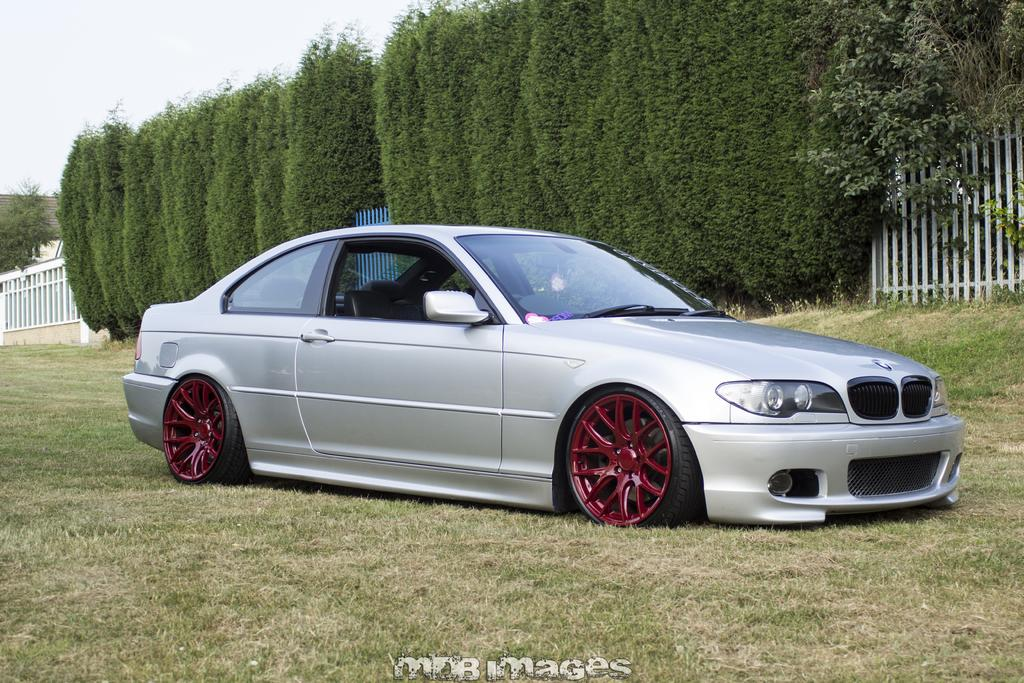What color is the car in the image? The car in the image is silver. Where is the car located in the image? The car is parked on the grass. What can be seen in the background of the image? There are trees, a fence, a roof, and the sky visible in the background of the image. How many snakes are crawling on the car in the image? There are no snakes present in the image; the car is parked on the grass with no visible animals. 